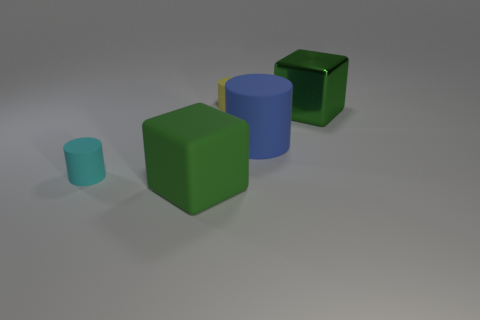Is the color of the big rubber thing on the left side of the big matte cylinder the same as the metallic object?
Your answer should be very brief. Yes. There is a blue matte thing that is the same size as the rubber block; what is its shape?
Your response must be concise. Cylinder. There is a matte cylinder that is left of the small yellow matte cylinder; what size is it?
Give a very brief answer. Small. There is a block that is behind the large green matte object; does it have the same color as the big block in front of the blue object?
Your answer should be very brief. Yes. The blue cylinder that is in front of the big green thing that is behind the rubber thing that is on the right side of the yellow cylinder is made of what material?
Provide a succinct answer. Rubber. Are there any cyan matte things of the same size as the yellow matte cylinder?
Ensure brevity in your answer.  Yes. What material is the other block that is the same size as the matte cube?
Offer a terse response. Metal. What is the shape of the green object that is behind the green rubber cube?
Offer a very short reply. Cube. Is the object behind the large green metallic object made of the same material as the green thing that is right of the yellow matte cylinder?
Offer a terse response. No. How many brown objects are the same shape as the small cyan rubber object?
Your response must be concise. 0. 